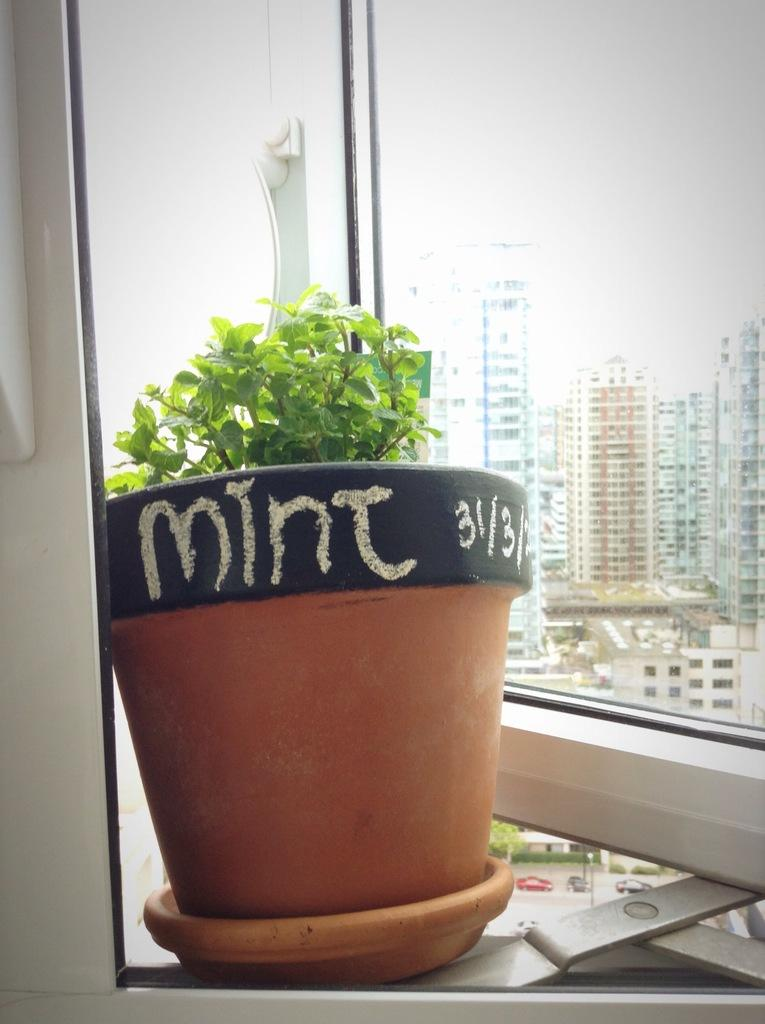What object is located on the left side of the image? There is a flower pot on the left side of the image. What is inside the flower pot? A small plant is present in the flower pot. What type of structures can be seen on the right side of the image? There are tall buildings visible on the right side of the image. How are the tall buildings visible in the image? The view of the tall buildings is through a window. What type of rose can be seen growing in the lake in the image? There is no rose or lake present in the image. 